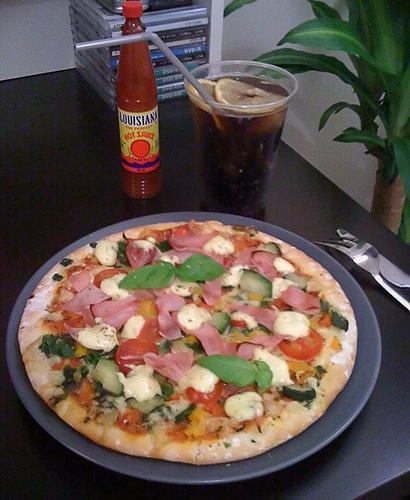How many pizzas are there?
Give a very brief answer. 1. How many CDs are there?
Give a very brief answer. 10. How many kinds of food?
Give a very brief answer. 1. How many pizzas are in the photo?
Give a very brief answer. 1. How many people in the picture?
Give a very brief answer. 0. 